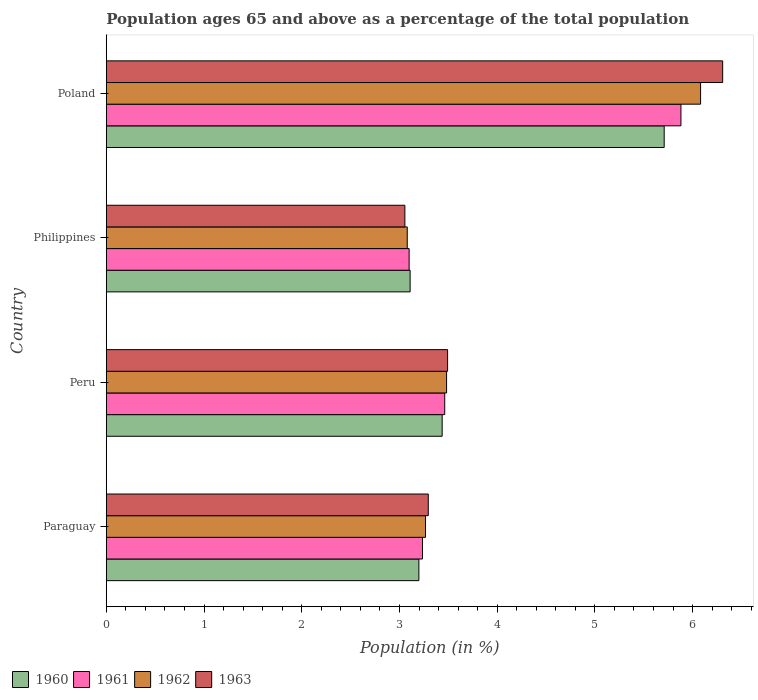How many different coloured bars are there?
Your response must be concise. 4. How many groups of bars are there?
Ensure brevity in your answer.  4. How many bars are there on the 2nd tick from the bottom?
Keep it short and to the point. 4. What is the label of the 3rd group of bars from the top?
Offer a terse response. Peru. In how many cases, is the number of bars for a given country not equal to the number of legend labels?
Provide a short and direct response. 0. What is the percentage of the population ages 65 and above in 1960 in Philippines?
Keep it short and to the point. 3.11. Across all countries, what is the maximum percentage of the population ages 65 and above in 1962?
Make the answer very short. 6.08. Across all countries, what is the minimum percentage of the population ages 65 and above in 1961?
Keep it short and to the point. 3.1. In which country was the percentage of the population ages 65 and above in 1962 minimum?
Make the answer very short. Philippines. What is the total percentage of the population ages 65 and above in 1962 in the graph?
Provide a succinct answer. 15.91. What is the difference between the percentage of the population ages 65 and above in 1960 in Peru and that in Poland?
Your response must be concise. -2.27. What is the difference between the percentage of the population ages 65 and above in 1961 in Poland and the percentage of the population ages 65 and above in 1962 in Philippines?
Provide a succinct answer. 2.8. What is the average percentage of the population ages 65 and above in 1963 per country?
Provide a succinct answer. 4.04. What is the difference between the percentage of the population ages 65 and above in 1962 and percentage of the population ages 65 and above in 1961 in Philippines?
Provide a short and direct response. -0.02. In how many countries, is the percentage of the population ages 65 and above in 1961 greater than 0.8 ?
Offer a very short reply. 4. What is the ratio of the percentage of the population ages 65 and above in 1961 in Peru to that in Philippines?
Keep it short and to the point. 1.12. Is the percentage of the population ages 65 and above in 1963 in Paraguay less than that in Peru?
Keep it short and to the point. Yes. Is the difference between the percentage of the population ages 65 and above in 1962 in Peru and Philippines greater than the difference between the percentage of the population ages 65 and above in 1961 in Peru and Philippines?
Provide a succinct answer. Yes. What is the difference between the highest and the second highest percentage of the population ages 65 and above in 1963?
Offer a very short reply. 2.82. What is the difference between the highest and the lowest percentage of the population ages 65 and above in 1963?
Offer a very short reply. 3.25. What does the 3rd bar from the top in Poland represents?
Ensure brevity in your answer.  1961. Are all the bars in the graph horizontal?
Give a very brief answer. Yes. How many countries are there in the graph?
Your response must be concise. 4. What is the difference between two consecutive major ticks on the X-axis?
Provide a short and direct response. 1. Are the values on the major ticks of X-axis written in scientific E-notation?
Offer a terse response. No. Does the graph contain any zero values?
Provide a succinct answer. No. Does the graph contain grids?
Give a very brief answer. No. Where does the legend appear in the graph?
Your answer should be very brief. Bottom left. How many legend labels are there?
Keep it short and to the point. 4. What is the title of the graph?
Your response must be concise. Population ages 65 and above as a percentage of the total population. What is the label or title of the Y-axis?
Your response must be concise. Country. What is the Population (in %) in 1960 in Paraguay?
Your answer should be very brief. 3.2. What is the Population (in %) of 1961 in Paraguay?
Your response must be concise. 3.24. What is the Population (in %) of 1962 in Paraguay?
Offer a very short reply. 3.27. What is the Population (in %) in 1963 in Paraguay?
Give a very brief answer. 3.29. What is the Population (in %) in 1960 in Peru?
Your answer should be very brief. 3.44. What is the Population (in %) in 1961 in Peru?
Ensure brevity in your answer.  3.46. What is the Population (in %) of 1962 in Peru?
Offer a terse response. 3.48. What is the Population (in %) of 1963 in Peru?
Offer a very short reply. 3.49. What is the Population (in %) in 1960 in Philippines?
Your response must be concise. 3.11. What is the Population (in %) of 1961 in Philippines?
Provide a succinct answer. 3.1. What is the Population (in %) in 1962 in Philippines?
Your answer should be compact. 3.08. What is the Population (in %) of 1963 in Philippines?
Your response must be concise. 3.06. What is the Population (in %) of 1960 in Poland?
Ensure brevity in your answer.  5.71. What is the Population (in %) in 1961 in Poland?
Give a very brief answer. 5.88. What is the Population (in %) in 1962 in Poland?
Your response must be concise. 6.08. What is the Population (in %) in 1963 in Poland?
Your answer should be very brief. 6.31. Across all countries, what is the maximum Population (in %) of 1960?
Offer a very short reply. 5.71. Across all countries, what is the maximum Population (in %) in 1961?
Give a very brief answer. 5.88. Across all countries, what is the maximum Population (in %) in 1962?
Your answer should be compact. 6.08. Across all countries, what is the maximum Population (in %) in 1963?
Your answer should be very brief. 6.31. Across all countries, what is the minimum Population (in %) in 1960?
Your answer should be very brief. 3.11. Across all countries, what is the minimum Population (in %) of 1961?
Give a very brief answer. 3.1. Across all countries, what is the minimum Population (in %) in 1962?
Give a very brief answer. 3.08. Across all countries, what is the minimum Population (in %) of 1963?
Provide a short and direct response. 3.06. What is the total Population (in %) in 1960 in the graph?
Make the answer very short. 15.45. What is the total Population (in %) of 1961 in the graph?
Keep it short and to the point. 15.68. What is the total Population (in %) of 1962 in the graph?
Give a very brief answer. 15.91. What is the total Population (in %) in 1963 in the graph?
Your response must be concise. 16.15. What is the difference between the Population (in %) in 1960 in Paraguay and that in Peru?
Offer a terse response. -0.24. What is the difference between the Population (in %) of 1961 in Paraguay and that in Peru?
Make the answer very short. -0.23. What is the difference between the Population (in %) in 1962 in Paraguay and that in Peru?
Offer a terse response. -0.22. What is the difference between the Population (in %) of 1963 in Paraguay and that in Peru?
Offer a very short reply. -0.2. What is the difference between the Population (in %) in 1960 in Paraguay and that in Philippines?
Give a very brief answer. 0.09. What is the difference between the Population (in %) of 1961 in Paraguay and that in Philippines?
Your answer should be compact. 0.14. What is the difference between the Population (in %) of 1962 in Paraguay and that in Philippines?
Provide a succinct answer. 0.19. What is the difference between the Population (in %) of 1963 in Paraguay and that in Philippines?
Keep it short and to the point. 0.24. What is the difference between the Population (in %) of 1960 in Paraguay and that in Poland?
Your answer should be compact. -2.51. What is the difference between the Population (in %) in 1961 in Paraguay and that in Poland?
Offer a terse response. -2.65. What is the difference between the Population (in %) of 1962 in Paraguay and that in Poland?
Make the answer very short. -2.82. What is the difference between the Population (in %) in 1963 in Paraguay and that in Poland?
Your answer should be compact. -3.01. What is the difference between the Population (in %) of 1960 in Peru and that in Philippines?
Offer a terse response. 0.33. What is the difference between the Population (in %) of 1961 in Peru and that in Philippines?
Ensure brevity in your answer.  0.36. What is the difference between the Population (in %) in 1962 in Peru and that in Philippines?
Your answer should be very brief. 0.4. What is the difference between the Population (in %) of 1963 in Peru and that in Philippines?
Your answer should be very brief. 0.44. What is the difference between the Population (in %) of 1960 in Peru and that in Poland?
Provide a succinct answer. -2.27. What is the difference between the Population (in %) in 1961 in Peru and that in Poland?
Make the answer very short. -2.42. What is the difference between the Population (in %) of 1962 in Peru and that in Poland?
Provide a succinct answer. -2.6. What is the difference between the Population (in %) in 1963 in Peru and that in Poland?
Provide a short and direct response. -2.82. What is the difference between the Population (in %) in 1960 in Philippines and that in Poland?
Keep it short and to the point. -2.6. What is the difference between the Population (in %) in 1961 in Philippines and that in Poland?
Make the answer very short. -2.78. What is the difference between the Population (in %) of 1962 in Philippines and that in Poland?
Provide a succinct answer. -3. What is the difference between the Population (in %) in 1963 in Philippines and that in Poland?
Keep it short and to the point. -3.25. What is the difference between the Population (in %) of 1960 in Paraguay and the Population (in %) of 1961 in Peru?
Your response must be concise. -0.26. What is the difference between the Population (in %) in 1960 in Paraguay and the Population (in %) in 1962 in Peru?
Offer a terse response. -0.28. What is the difference between the Population (in %) in 1960 in Paraguay and the Population (in %) in 1963 in Peru?
Provide a succinct answer. -0.29. What is the difference between the Population (in %) of 1961 in Paraguay and the Population (in %) of 1962 in Peru?
Make the answer very short. -0.25. What is the difference between the Population (in %) of 1961 in Paraguay and the Population (in %) of 1963 in Peru?
Your response must be concise. -0.26. What is the difference between the Population (in %) of 1962 in Paraguay and the Population (in %) of 1963 in Peru?
Your response must be concise. -0.23. What is the difference between the Population (in %) in 1960 in Paraguay and the Population (in %) in 1961 in Philippines?
Provide a short and direct response. 0.1. What is the difference between the Population (in %) in 1960 in Paraguay and the Population (in %) in 1962 in Philippines?
Keep it short and to the point. 0.12. What is the difference between the Population (in %) in 1960 in Paraguay and the Population (in %) in 1963 in Philippines?
Provide a succinct answer. 0.14. What is the difference between the Population (in %) in 1961 in Paraguay and the Population (in %) in 1962 in Philippines?
Keep it short and to the point. 0.16. What is the difference between the Population (in %) in 1961 in Paraguay and the Population (in %) in 1963 in Philippines?
Give a very brief answer. 0.18. What is the difference between the Population (in %) of 1962 in Paraguay and the Population (in %) of 1963 in Philippines?
Give a very brief answer. 0.21. What is the difference between the Population (in %) in 1960 in Paraguay and the Population (in %) in 1961 in Poland?
Ensure brevity in your answer.  -2.68. What is the difference between the Population (in %) in 1960 in Paraguay and the Population (in %) in 1962 in Poland?
Your response must be concise. -2.88. What is the difference between the Population (in %) of 1960 in Paraguay and the Population (in %) of 1963 in Poland?
Offer a terse response. -3.11. What is the difference between the Population (in %) in 1961 in Paraguay and the Population (in %) in 1962 in Poland?
Ensure brevity in your answer.  -2.85. What is the difference between the Population (in %) of 1961 in Paraguay and the Population (in %) of 1963 in Poland?
Offer a very short reply. -3.07. What is the difference between the Population (in %) in 1962 in Paraguay and the Population (in %) in 1963 in Poland?
Provide a succinct answer. -3.04. What is the difference between the Population (in %) of 1960 in Peru and the Population (in %) of 1961 in Philippines?
Offer a very short reply. 0.34. What is the difference between the Population (in %) of 1960 in Peru and the Population (in %) of 1962 in Philippines?
Offer a terse response. 0.36. What is the difference between the Population (in %) of 1960 in Peru and the Population (in %) of 1963 in Philippines?
Keep it short and to the point. 0.38. What is the difference between the Population (in %) in 1961 in Peru and the Population (in %) in 1962 in Philippines?
Offer a terse response. 0.38. What is the difference between the Population (in %) of 1961 in Peru and the Population (in %) of 1963 in Philippines?
Give a very brief answer. 0.41. What is the difference between the Population (in %) of 1962 in Peru and the Population (in %) of 1963 in Philippines?
Make the answer very short. 0.43. What is the difference between the Population (in %) of 1960 in Peru and the Population (in %) of 1961 in Poland?
Offer a very short reply. -2.44. What is the difference between the Population (in %) of 1960 in Peru and the Population (in %) of 1962 in Poland?
Your response must be concise. -2.64. What is the difference between the Population (in %) in 1960 in Peru and the Population (in %) in 1963 in Poland?
Provide a succinct answer. -2.87. What is the difference between the Population (in %) in 1961 in Peru and the Population (in %) in 1962 in Poland?
Offer a terse response. -2.62. What is the difference between the Population (in %) of 1961 in Peru and the Population (in %) of 1963 in Poland?
Provide a short and direct response. -2.84. What is the difference between the Population (in %) in 1962 in Peru and the Population (in %) in 1963 in Poland?
Your response must be concise. -2.83. What is the difference between the Population (in %) in 1960 in Philippines and the Population (in %) in 1961 in Poland?
Your answer should be compact. -2.77. What is the difference between the Population (in %) in 1960 in Philippines and the Population (in %) in 1962 in Poland?
Give a very brief answer. -2.97. What is the difference between the Population (in %) in 1960 in Philippines and the Population (in %) in 1963 in Poland?
Make the answer very short. -3.2. What is the difference between the Population (in %) of 1961 in Philippines and the Population (in %) of 1962 in Poland?
Keep it short and to the point. -2.98. What is the difference between the Population (in %) of 1961 in Philippines and the Population (in %) of 1963 in Poland?
Offer a very short reply. -3.21. What is the difference between the Population (in %) of 1962 in Philippines and the Population (in %) of 1963 in Poland?
Provide a short and direct response. -3.23. What is the average Population (in %) of 1960 per country?
Keep it short and to the point. 3.86. What is the average Population (in %) of 1961 per country?
Provide a succinct answer. 3.92. What is the average Population (in %) in 1962 per country?
Your answer should be compact. 3.98. What is the average Population (in %) of 1963 per country?
Provide a short and direct response. 4.04. What is the difference between the Population (in %) of 1960 and Population (in %) of 1961 in Paraguay?
Provide a short and direct response. -0.04. What is the difference between the Population (in %) of 1960 and Population (in %) of 1962 in Paraguay?
Provide a short and direct response. -0.07. What is the difference between the Population (in %) of 1960 and Population (in %) of 1963 in Paraguay?
Keep it short and to the point. -0.1. What is the difference between the Population (in %) in 1961 and Population (in %) in 1962 in Paraguay?
Your answer should be very brief. -0.03. What is the difference between the Population (in %) of 1961 and Population (in %) of 1963 in Paraguay?
Your answer should be compact. -0.06. What is the difference between the Population (in %) of 1962 and Population (in %) of 1963 in Paraguay?
Keep it short and to the point. -0.03. What is the difference between the Population (in %) of 1960 and Population (in %) of 1961 in Peru?
Your answer should be compact. -0.03. What is the difference between the Population (in %) in 1960 and Population (in %) in 1962 in Peru?
Provide a short and direct response. -0.05. What is the difference between the Population (in %) of 1960 and Population (in %) of 1963 in Peru?
Offer a very short reply. -0.06. What is the difference between the Population (in %) of 1961 and Population (in %) of 1962 in Peru?
Offer a very short reply. -0.02. What is the difference between the Population (in %) in 1961 and Population (in %) in 1963 in Peru?
Keep it short and to the point. -0.03. What is the difference between the Population (in %) of 1962 and Population (in %) of 1963 in Peru?
Offer a terse response. -0.01. What is the difference between the Population (in %) in 1960 and Population (in %) in 1961 in Philippines?
Make the answer very short. 0.01. What is the difference between the Population (in %) of 1960 and Population (in %) of 1962 in Philippines?
Your answer should be compact. 0.03. What is the difference between the Population (in %) in 1960 and Population (in %) in 1963 in Philippines?
Provide a short and direct response. 0.05. What is the difference between the Population (in %) in 1961 and Population (in %) in 1962 in Philippines?
Offer a terse response. 0.02. What is the difference between the Population (in %) of 1961 and Population (in %) of 1963 in Philippines?
Your answer should be compact. 0.04. What is the difference between the Population (in %) of 1962 and Population (in %) of 1963 in Philippines?
Your response must be concise. 0.02. What is the difference between the Population (in %) of 1960 and Population (in %) of 1961 in Poland?
Your answer should be very brief. -0.17. What is the difference between the Population (in %) of 1960 and Population (in %) of 1962 in Poland?
Make the answer very short. -0.37. What is the difference between the Population (in %) in 1960 and Population (in %) in 1963 in Poland?
Your answer should be very brief. -0.6. What is the difference between the Population (in %) in 1961 and Population (in %) in 1962 in Poland?
Your answer should be compact. -0.2. What is the difference between the Population (in %) of 1961 and Population (in %) of 1963 in Poland?
Your response must be concise. -0.43. What is the difference between the Population (in %) in 1962 and Population (in %) in 1963 in Poland?
Your answer should be compact. -0.23. What is the ratio of the Population (in %) of 1960 in Paraguay to that in Peru?
Provide a succinct answer. 0.93. What is the ratio of the Population (in %) in 1961 in Paraguay to that in Peru?
Provide a succinct answer. 0.93. What is the ratio of the Population (in %) in 1962 in Paraguay to that in Peru?
Keep it short and to the point. 0.94. What is the ratio of the Population (in %) of 1963 in Paraguay to that in Peru?
Offer a terse response. 0.94. What is the ratio of the Population (in %) in 1960 in Paraguay to that in Philippines?
Provide a succinct answer. 1.03. What is the ratio of the Population (in %) in 1961 in Paraguay to that in Philippines?
Provide a succinct answer. 1.04. What is the ratio of the Population (in %) in 1962 in Paraguay to that in Philippines?
Your response must be concise. 1.06. What is the ratio of the Population (in %) in 1963 in Paraguay to that in Philippines?
Provide a succinct answer. 1.08. What is the ratio of the Population (in %) in 1960 in Paraguay to that in Poland?
Offer a very short reply. 0.56. What is the ratio of the Population (in %) in 1961 in Paraguay to that in Poland?
Provide a succinct answer. 0.55. What is the ratio of the Population (in %) in 1962 in Paraguay to that in Poland?
Offer a very short reply. 0.54. What is the ratio of the Population (in %) in 1963 in Paraguay to that in Poland?
Offer a terse response. 0.52. What is the ratio of the Population (in %) of 1960 in Peru to that in Philippines?
Your answer should be very brief. 1.11. What is the ratio of the Population (in %) in 1961 in Peru to that in Philippines?
Make the answer very short. 1.12. What is the ratio of the Population (in %) of 1962 in Peru to that in Philippines?
Ensure brevity in your answer.  1.13. What is the ratio of the Population (in %) of 1963 in Peru to that in Philippines?
Keep it short and to the point. 1.14. What is the ratio of the Population (in %) in 1960 in Peru to that in Poland?
Keep it short and to the point. 0.6. What is the ratio of the Population (in %) of 1961 in Peru to that in Poland?
Your response must be concise. 0.59. What is the ratio of the Population (in %) of 1962 in Peru to that in Poland?
Offer a terse response. 0.57. What is the ratio of the Population (in %) in 1963 in Peru to that in Poland?
Give a very brief answer. 0.55. What is the ratio of the Population (in %) of 1960 in Philippines to that in Poland?
Keep it short and to the point. 0.54. What is the ratio of the Population (in %) of 1961 in Philippines to that in Poland?
Keep it short and to the point. 0.53. What is the ratio of the Population (in %) in 1962 in Philippines to that in Poland?
Make the answer very short. 0.51. What is the ratio of the Population (in %) of 1963 in Philippines to that in Poland?
Keep it short and to the point. 0.48. What is the difference between the highest and the second highest Population (in %) in 1960?
Give a very brief answer. 2.27. What is the difference between the highest and the second highest Population (in %) of 1961?
Your answer should be very brief. 2.42. What is the difference between the highest and the second highest Population (in %) of 1962?
Offer a very short reply. 2.6. What is the difference between the highest and the second highest Population (in %) in 1963?
Your answer should be compact. 2.82. What is the difference between the highest and the lowest Population (in %) in 1960?
Keep it short and to the point. 2.6. What is the difference between the highest and the lowest Population (in %) of 1961?
Offer a very short reply. 2.78. What is the difference between the highest and the lowest Population (in %) of 1962?
Provide a short and direct response. 3. What is the difference between the highest and the lowest Population (in %) in 1963?
Your answer should be compact. 3.25. 